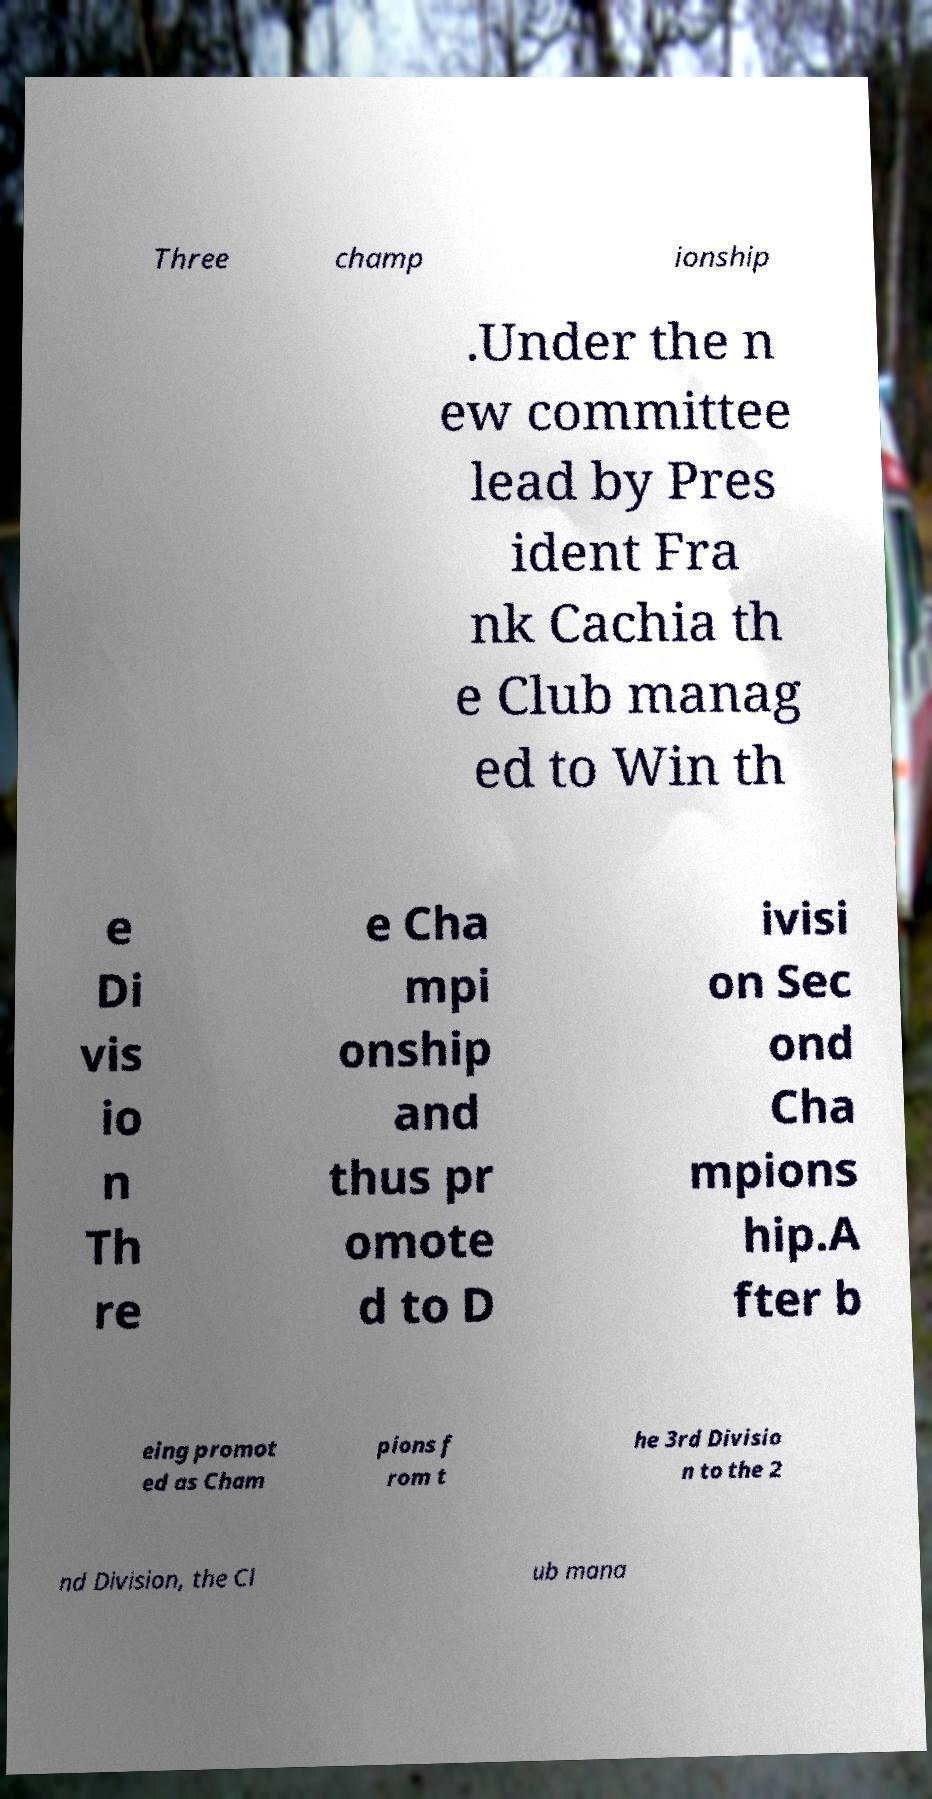For documentation purposes, I need the text within this image transcribed. Could you provide that? Three champ ionship .Under the n ew committee lead by Pres ident Fra nk Cachia th e Club manag ed to Win th e Di vis io n Th re e Cha mpi onship and thus pr omote d to D ivisi on Sec ond Cha mpions hip.A fter b eing promot ed as Cham pions f rom t he 3rd Divisio n to the 2 nd Division, the Cl ub mana 